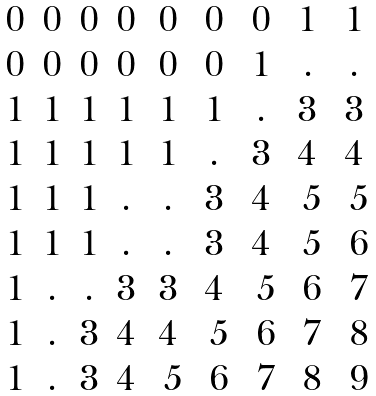<formula> <loc_0><loc_0><loc_500><loc_500>\begin{matrix} 0 & 0 & 0 & 0 & 0 & 0 & 0 & 1 & 1 \\ 0 & 0 & 0 & 0 & 0 & 0 & 1 & . & . \\ 1 & 1 & 1 & 1 & 1 & 1 & . & 3 & 3 \\ 1 & 1 & 1 & 1 & 1 & . & 3 & 4 & 4 \\ 1 & 1 & 1 & . & . & 3 & 4 & \ 5 & \ 5 \\ 1 & 1 & 1 & . & . & 3 & 4 & \ 5 & \ 6 \\ 1 & . & . & 3 & 3 & 4 & \ 5 & \ 6 & \ 7 \\ 1 & . & 3 & 4 & 4 & \ 5 & \ 6 & \ 7 & \ 8 \\ 1 & . & 3 & 4 & \ 5 & \ 6 & \ 7 & \ 8 & \ 9 \end{matrix}</formula> 